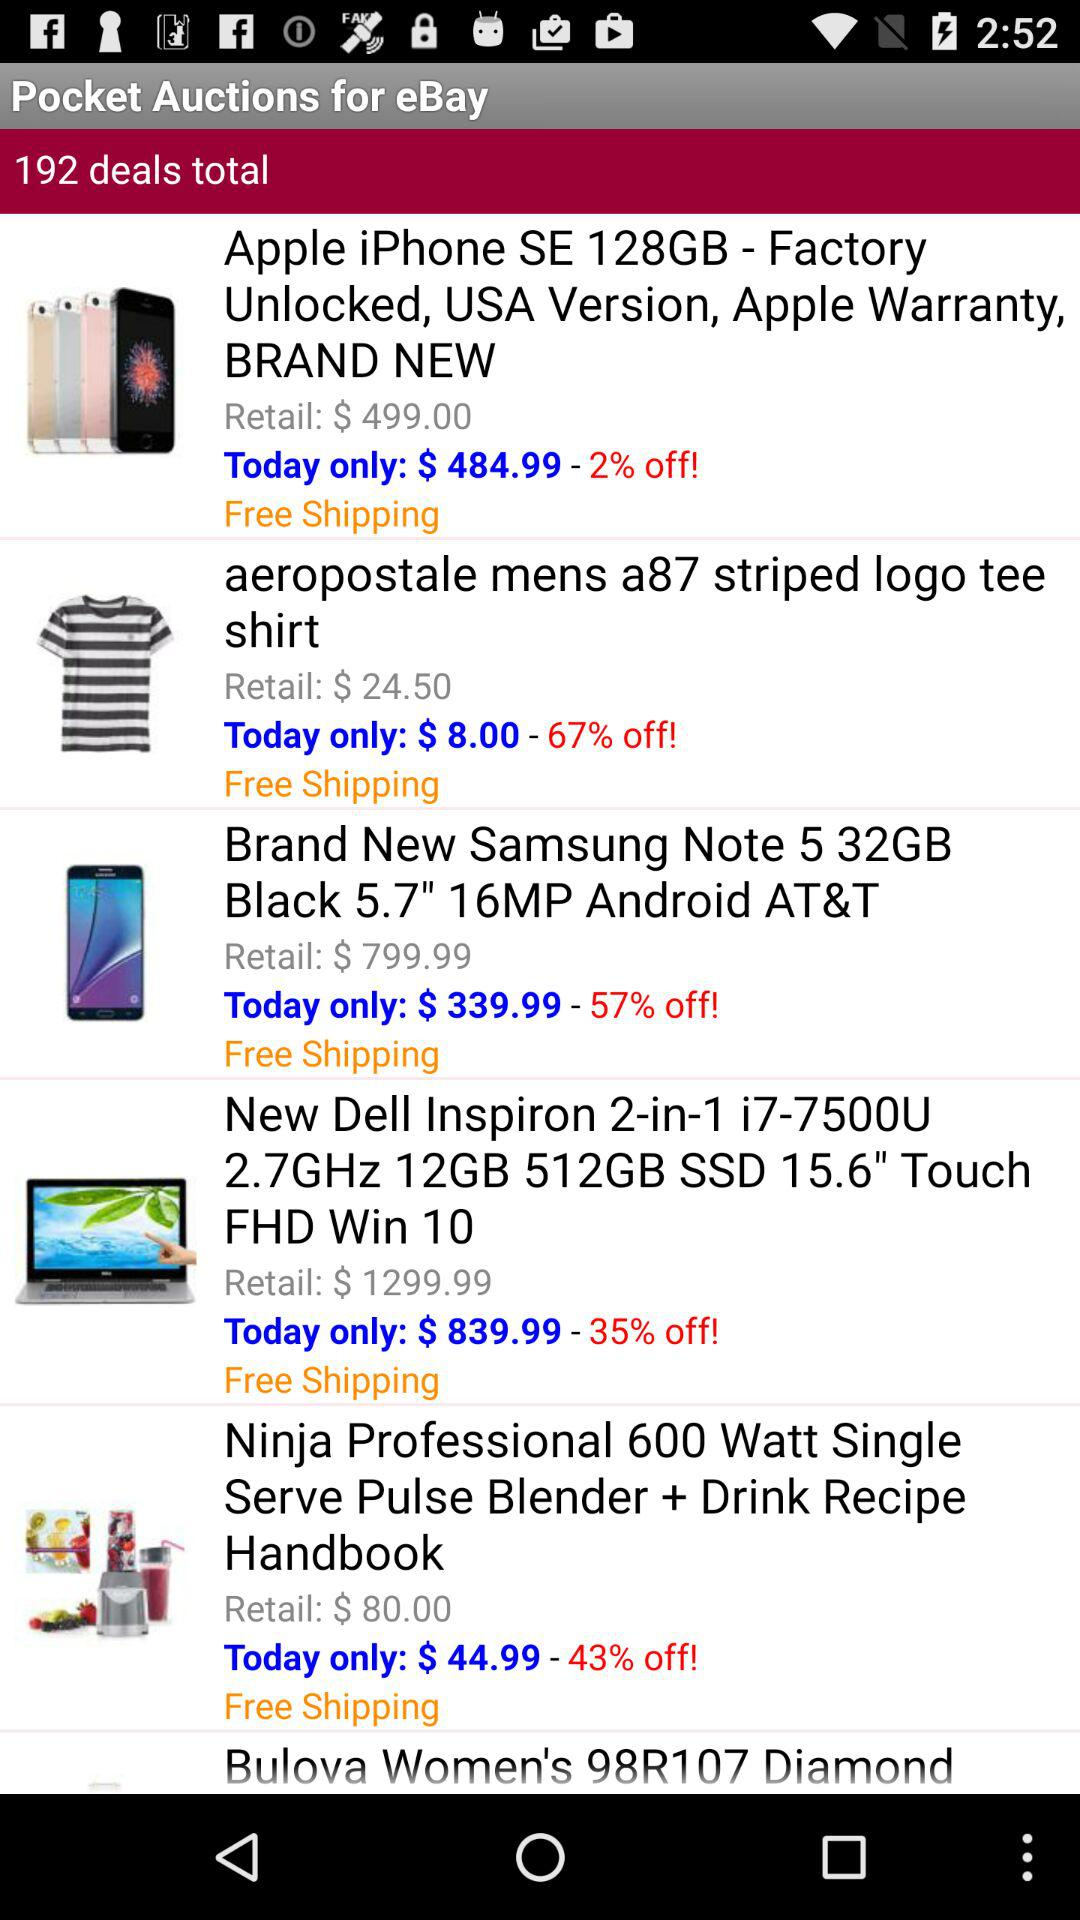How much is the price of a "Brand New Samsung Note 5 32GB Black 5.7" 16MP Android AT&T" available in today's deal? The price is $339.99. 